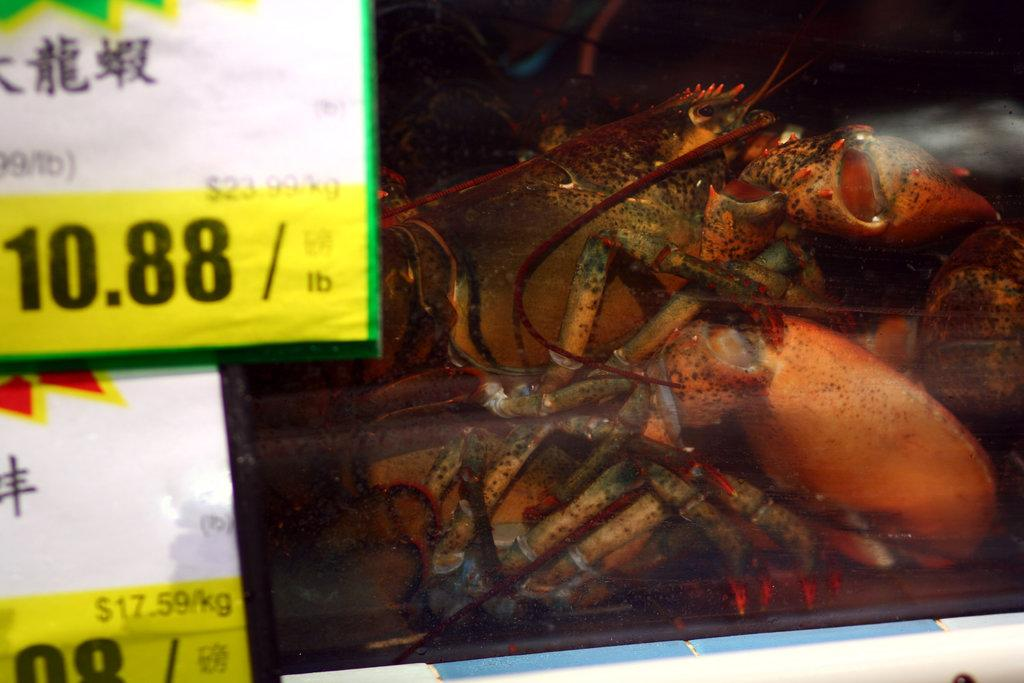What type of food is visible in the image? There is seafood in the image. How is the seafood being stored or presented? The seafood is packed in a cover. Are there any additional details about the seafood packaging? Price tags are present on the cover. Is there any blood visible on the seafood in the image? There is no blood visible on the seafood in the image. What type of rail can be seen in the image? There is no rail present in the image. 